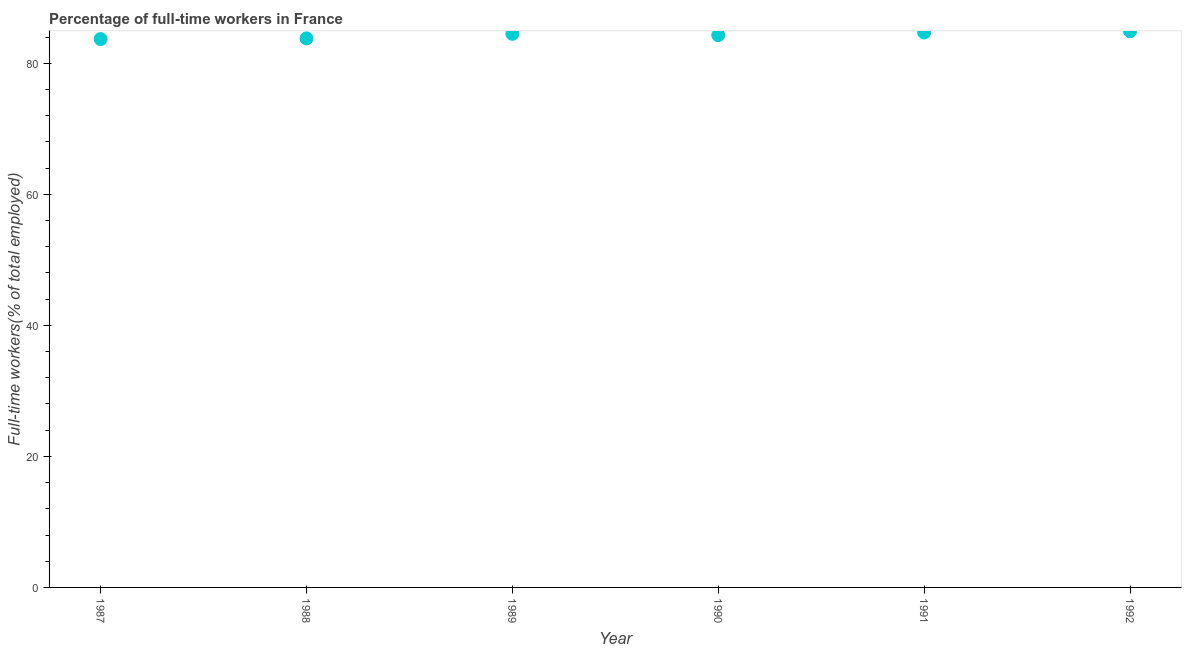What is the percentage of full-time workers in 1989?
Ensure brevity in your answer.  84.5. Across all years, what is the maximum percentage of full-time workers?
Provide a succinct answer. 84.9. Across all years, what is the minimum percentage of full-time workers?
Provide a succinct answer. 83.7. In which year was the percentage of full-time workers maximum?
Keep it short and to the point. 1992. What is the sum of the percentage of full-time workers?
Keep it short and to the point. 505.9. What is the difference between the percentage of full-time workers in 1989 and 1990?
Ensure brevity in your answer.  0.2. What is the average percentage of full-time workers per year?
Provide a succinct answer. 84.32. What is the median percentage of full-time workers?
Make the answer very short. 84.4. What is the ratio of the percentage of full-time workers in 1987 to that in 1988?
Your answer should be very brief. 1. What is the difference between the highest and the second highest percentage of full-time workers?
Make the answer very short. 0.2. What is the difference between the highest and the lowest percentage of full-time workers?
Keep it short and to the point. 1.2. How many dotlines are there?
Your response must be concise. 1. Are the values on the major ticks of Y-axis written in scientific E-notation?
Give a very brief answer. No. Does the graph contain any zero values?
Provide a succinct answer. No. What is the title of the graph?
Your answer should be compact. Percentage of full-time workers in France. What is the label or title of the Y-axis?
Give a very brief answer. Full-time workers(% of total employed). What is the Full-time workers(% of total employed) in 1987?
Your response must be concise. 83.7. What is the Full-time workers(% of total employed) in 1988?
Offer a very short reply. 83.8. What is the Full-time workers(% of total employed) in 1989?
Your answer should be very brief. 84.5. What is the Full-time workers(% of total employed) in 1990?
Give a very brief answer. 84.3. What is the Full-time workers(% of total employed) in 1991?
Offer a terse response. 84.7. What is the Full-time workers(% of total employed) in 1992?
Give a very brief answer. 84.9. What is the difference between the Full-time workers(% of total employed) in 1987 and 1988?
Your answer should be compact. -0.1. What is the difference between the Full-time workers(% of total employed) in 1987 and 1990?
Provide a succinct answer. -0.6. What is the difference between the Full-time workers(% of total employed) in 1987 and 1991?
Provide a succinct answer. -1. What is the difference between the Full-time workers(% of total employed) in 1987 and 1992?
Offer a very short reply. -1.2. What is the difference between the Full-time workers(% of total employed) in 1988 and 1989?
Make the answer very short. -0.7. What is the difference between the Full-time workers(% of total employed) in 1988 and 1991?
Your answer should be compact. -0.9. What is the difference between the Full-time workers(% of total employed) in 1989 and 1990?
Offer a terse response. 0.2. What is the difference between the Full-time workers(% of total employed) in 1990 and 1991?
Offer a terse response. -0.4. What is the ratio of the Full-time workers(% of total employed) in 1987 to that in 1988?
Provide a succinct answer. 1. What is the ratio of the Full-time workers(% of total employed) in 1987 to that in 1990?
Offer a very short reply. 0.99. What is the ratio of the Full-time workers(% of total employed) in 1987 to that in 1991?
Give a very brief answer. 0.99. What is the ratio of the Full-time workers(% of total employed) in 1987 to that in 1992?
Provide a succinct answer. 0.99. What is the ratio of the Full-time workers(% of total employed) in 1988 to that in 1989?
Ensure brevity in your answer.  0.99. What is the ratio of the Full-time workers(% of total employed) in 1988 to that in 1990?
Your answer should be compact. 0.99. What is the ratio of the Full-time workers(% of total employed) in 1989 to that in 1990?
Offer a terse response. 1. What is the ratio of the Full-time workers(% of total employed) in 1989 to that in 1991?
Your response must be concise. 1. What is the ratio of the Full-time workers(% of total employed) in 1991 to that in 1992?
Your response must be concise. 1. 